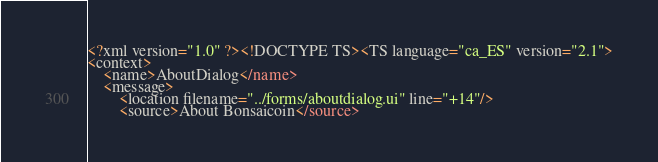Convert code to text. <code><loc_0><loc_0><loc_500><loc_500><_TypeScript_><?xml version="1.0" ?><!DOCTYPE TS><TS language="ca_ES" version="2.1">
<context>
    <name>AboutDialog</name>
    <message>
        <location filename="../forms/aboutdialog.ui" line="+14"/>
        <source>About Bonsaicoin</source></code> 